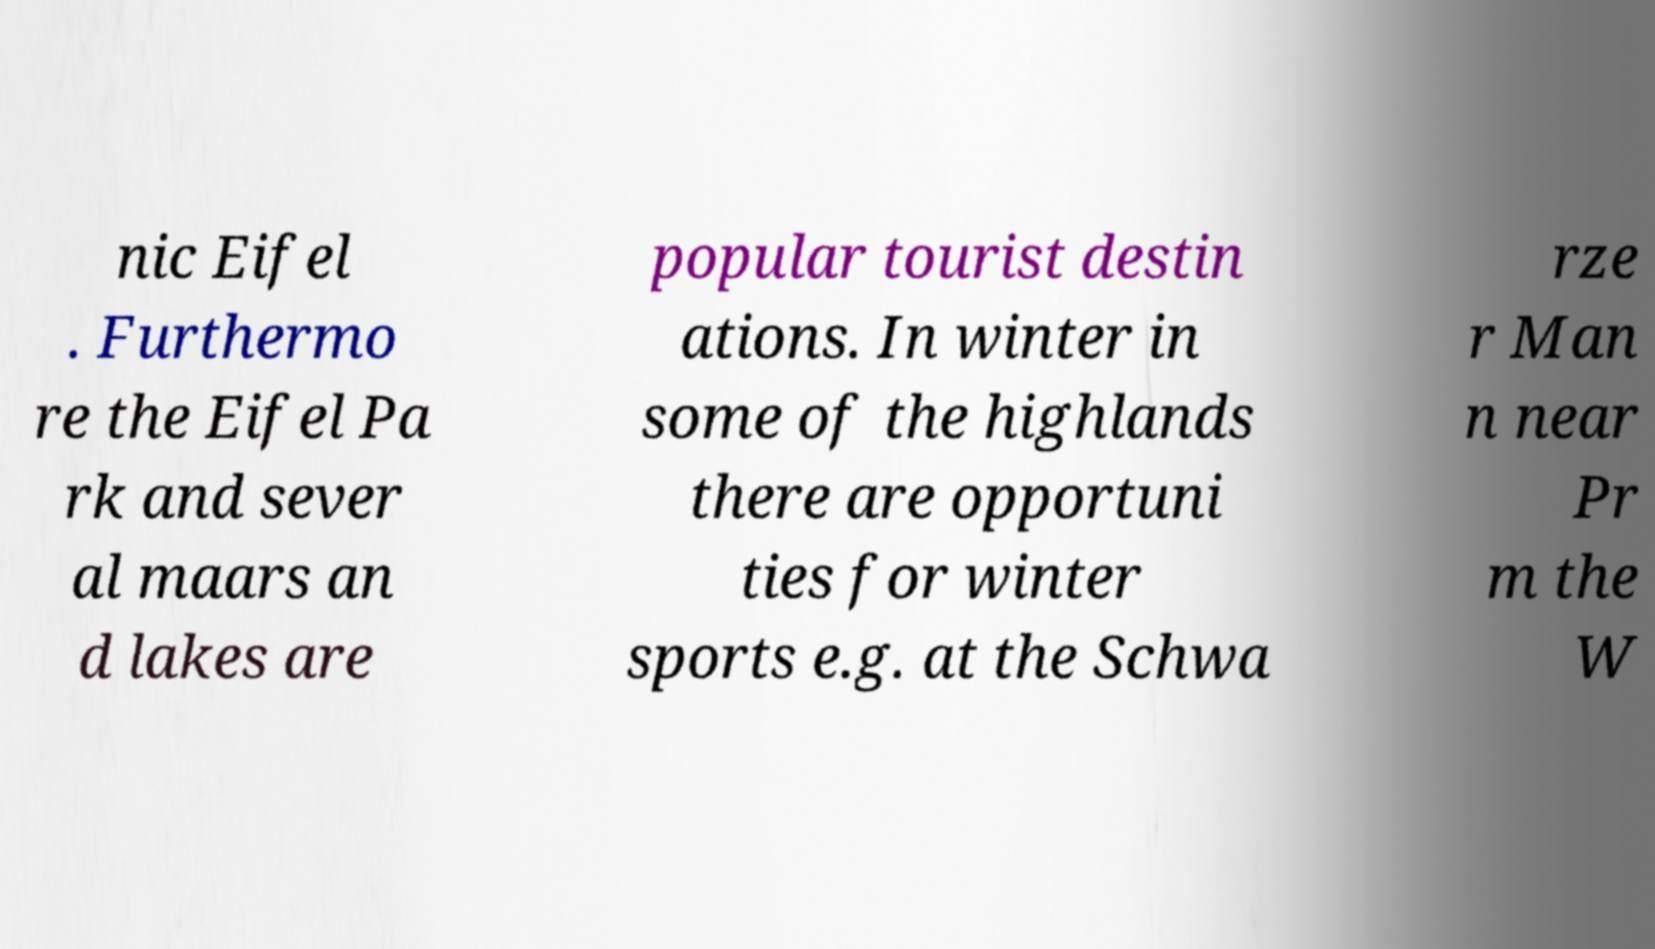I need the written content from this picture converted into text. Can you do that? nic Eifel . Furthermo re the Eifel Pa rk and sever al maars an d lakes are popular tourist destin ations. In winter in some of the highlands there are opportuni ties for winter sports e.g. at the Schwa rze r Man n near Pr m the W 